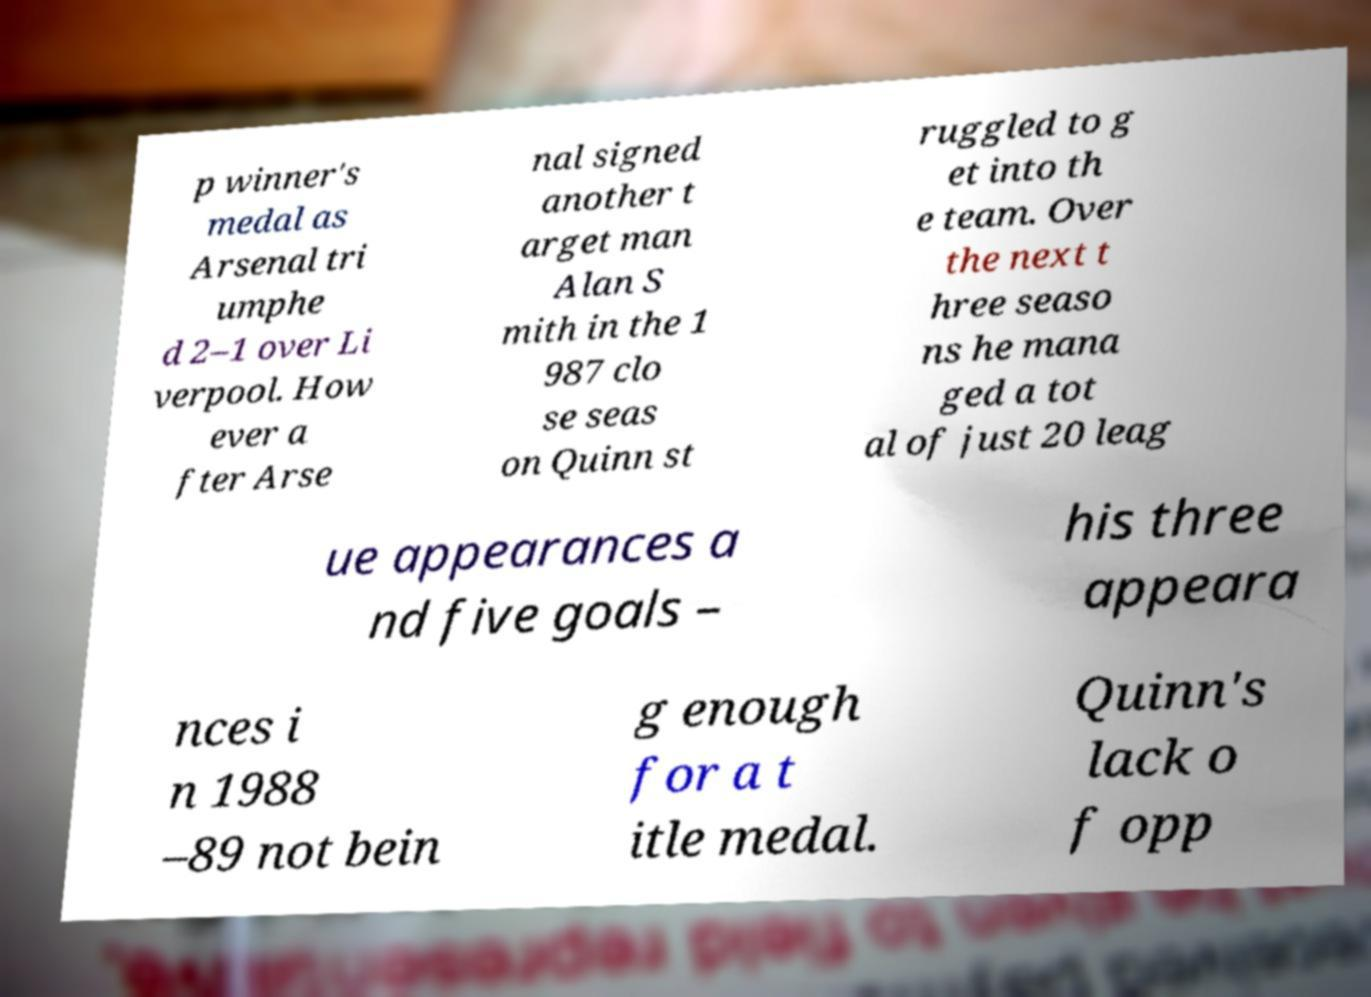Can you accurately transcribe the text from the provided image for me? p winner's medal as Arsenal tri umphe d 2–1 over Li verpool. How ever a fter Arse nal signed another t arget man Alan S mith in the 1 987 clo se seas on Quinn st ruggled to g et into th e team. Over the next t hree seaso ns he mana ged a tot al of just 20 leag ue appearances a nd five goals – his three appeara nces i n 1988 –89 not bein g enough for a t itle medal. Quinn's lack o f opp 